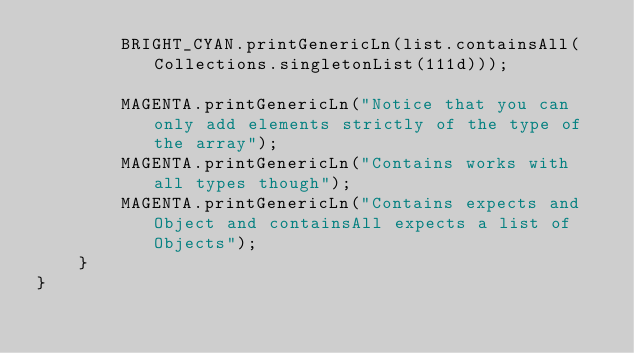Convert code to text. <code><loc_0><loc_0><loc_500><loc_500><_Java_>        BRIGHT_CYAN.printGenericLn(list.containsAll(Collections.singletonList(111d)));

        MAGENTA.printGenericLn("Notice that you can only add elements strictly of the type of the array");
        MAGENTA.printGenericLn("Contains works with all types though");
        MAGENTA.printGenericLn("Contains expects and Object and containsAll expects a list of Objects");
    }
}
</code> 